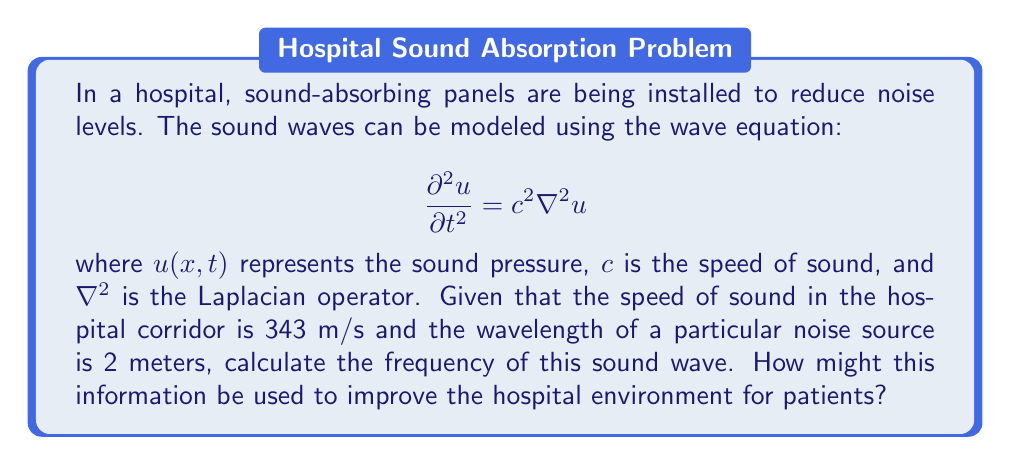What is the answer to this math problem? To solve this problem, we'll use the relationship between wave speed, frequency, and wavelength:

1) The general equation relating these quantities is:
   $$c = f \lambda$$
   where $c$ is the wave speed, $f$ is the frequency, and $\lambda$ is the wavelength.

2) We are given:
   - Speed of sound, $c = 343$ m/s
   - Wavelength, $\lambda = 2$ m

3) Substituting these values into the equation:
   $$343 = f \cdot 2$$

4) Solving for $f$:
   $$f = \frac{343}{2} = 171.5 \text{ Hz}$$

5) This frequency falls within the range of human hearing (20 Hz to 20 kHz).

6) To improve the hospital environment:
   - Identify common noise sources at this frequency
   - Design sound-absorbing panels to target this specific frequency
   - Implement noise reduction strategies focusing on this frequency range
   - Educate staff on the importance of noise control at this frequency

This approach can help create a more peaceful environment for patients, potentially improving recovery times and overall patient satisfaction.
Answer: 171.5 Hz 